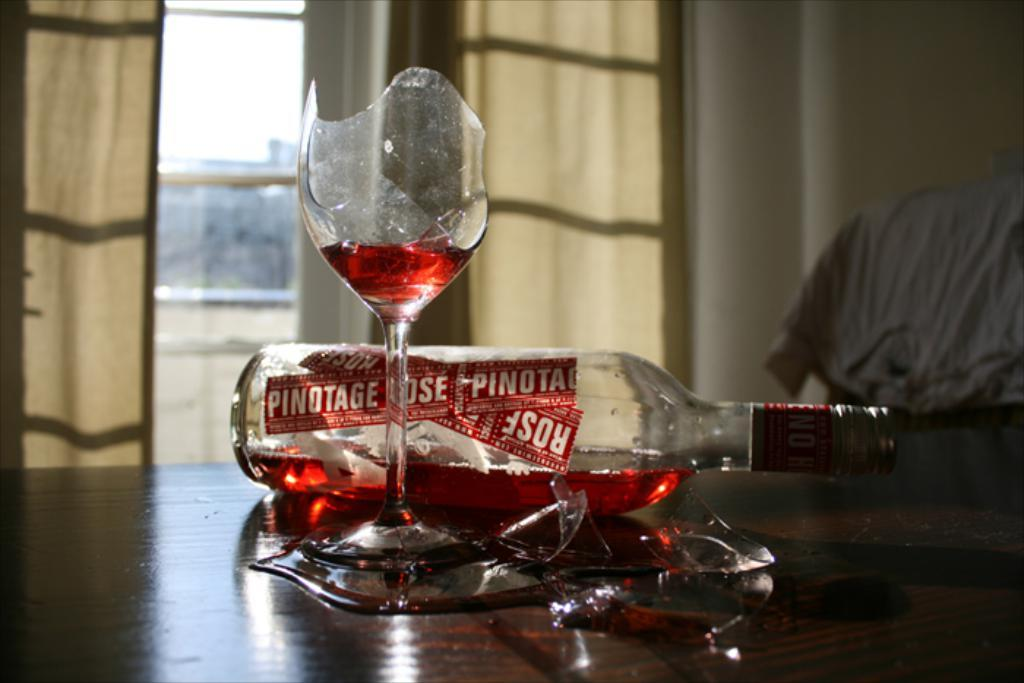What type of surface is visible in the image? There is a wooden surface in the image. What objects are placed on the wooden surface? There is a bottle and a glass on the wooden surface. Can you describe the background of the image? The background of the image is blurred. What type of window treatment is present in the image? There are curtains in the image. What type of material is visible in the image? There is cloth in the image. How many snakes are slithering on the wooden surface in the image? There are no snakes present in the image; it only features a bottle and a glass on the wooden surface. What is the relation between the bottle and the glass in the image? The provided facts do not give any information about a relation between the bottle and the glass; they are simply objects placed on the wooden surface. 